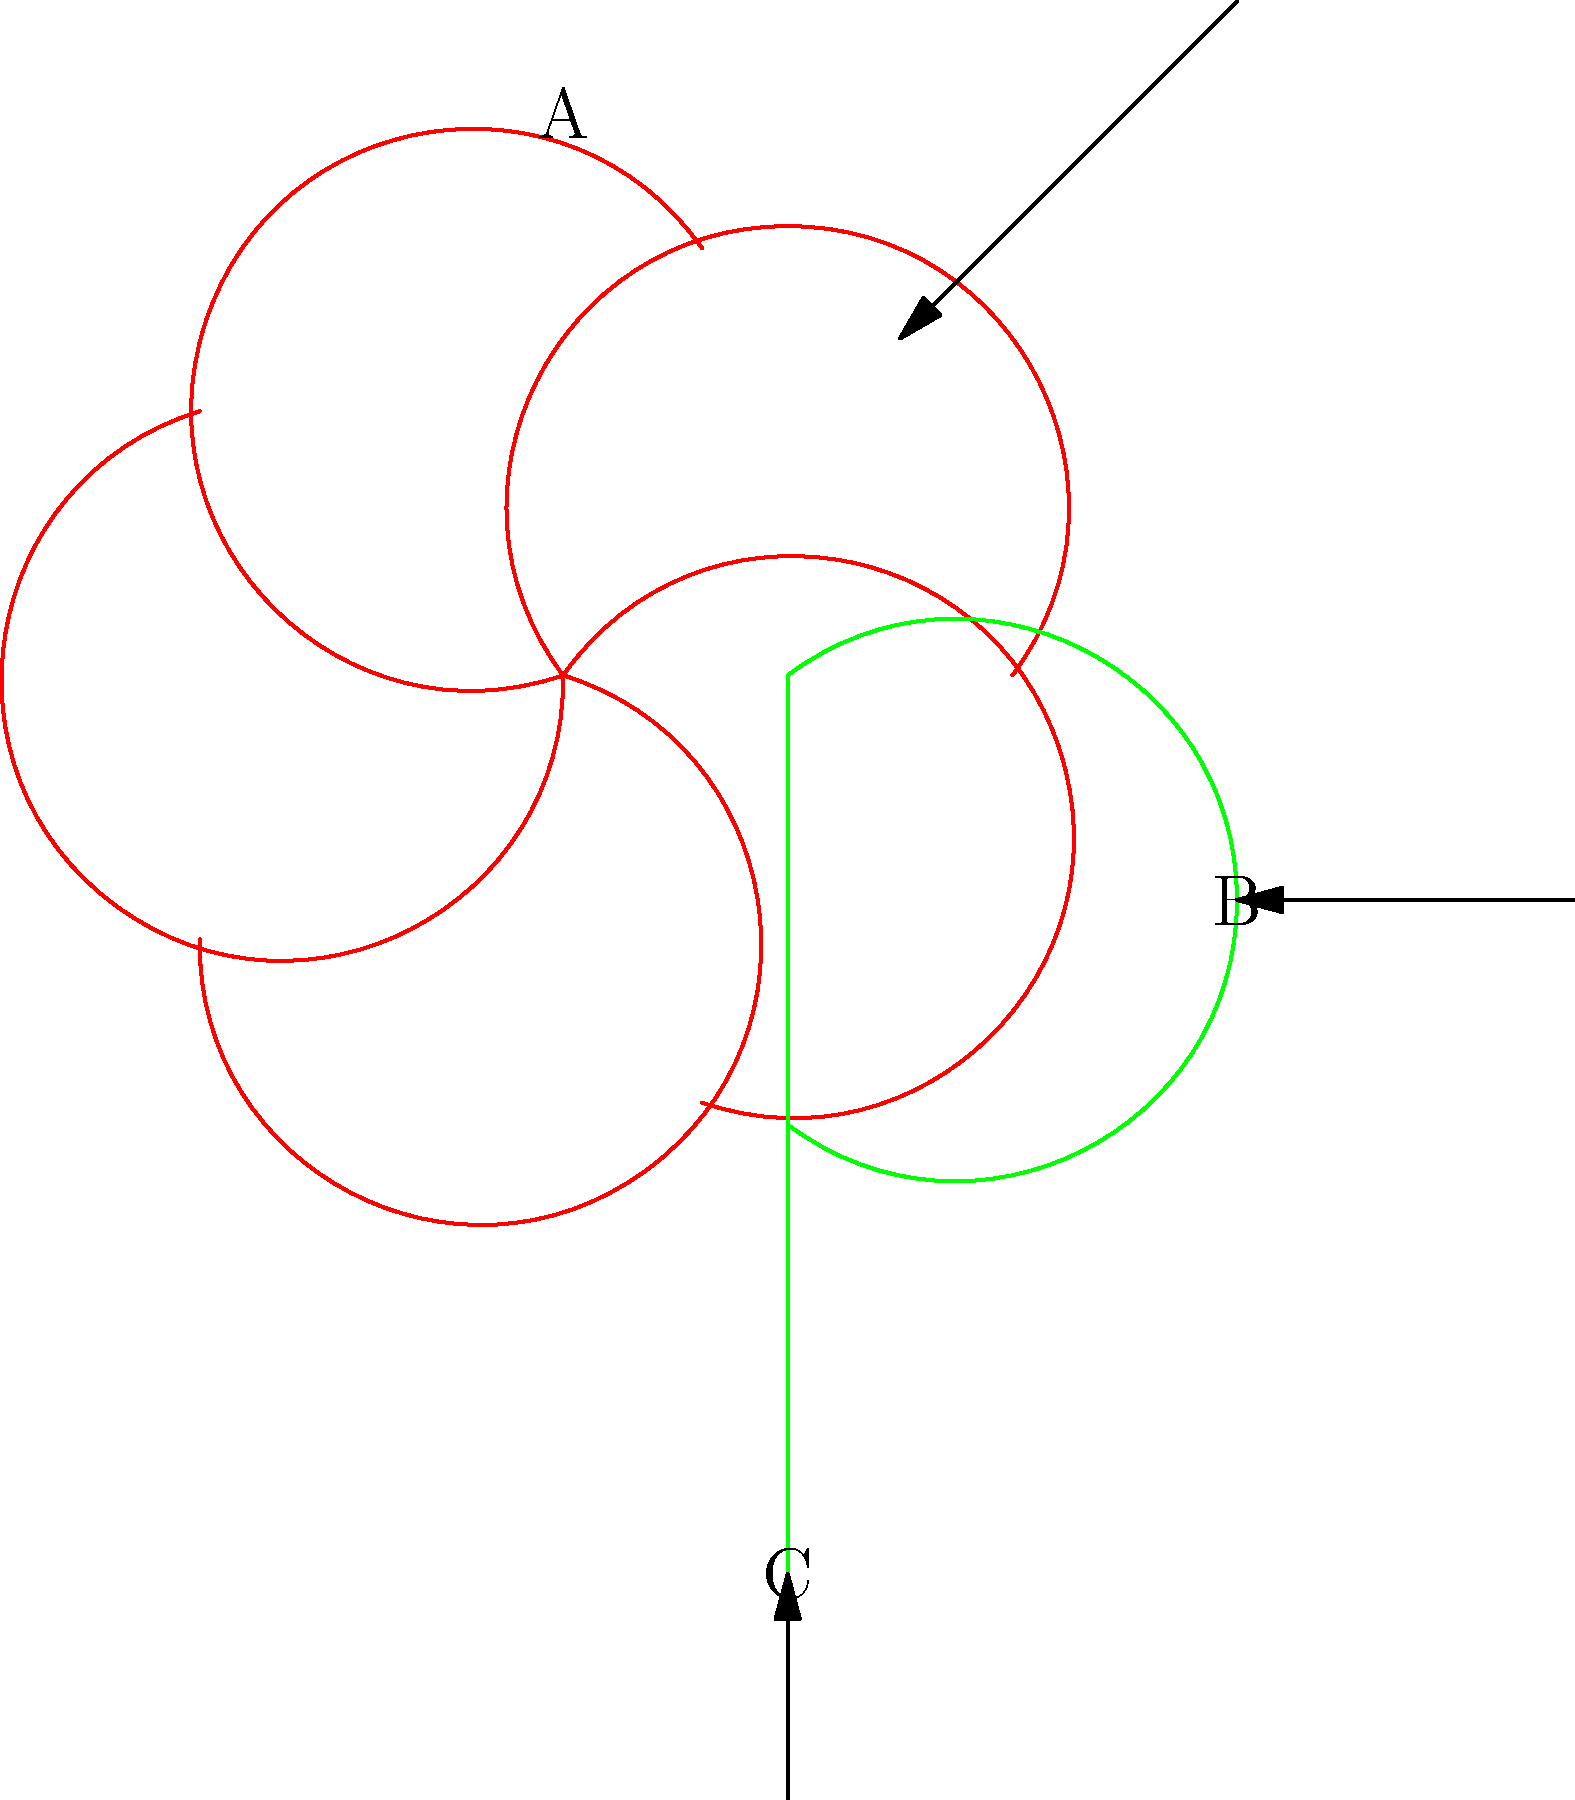Identify the structures labeled A, B, and C in the botanical drawing above. Which of these structures is most useful for taxonomic classification at the family level, and why? To answer this question, let's analyze each labeled structure:

1. Structure A: This represents the flower, which is composed of multiple petals arranged in a radial pattern. Flowers are reproductive structures in angiosperms.

2. Structure B: This is a leaf, an organ primarily responsible for photosynthesis in plants.

3. Structure C: This is the stem, which provides support and conducts water and nutrients throughout the plant.

Among these structures, the flower (A) is most useful for taxonomic classification at the family level. Here's why:

1. Floral characteristics are highly conserved within plant families and are less influenced by environmental factors compared to leaves or stems.

2. Flowers contain multiple features that are taxonomically significant, such as:
   a. Number of petals, sepals, stamens, and carpels
   b. Fusion or separation of floral parts
   c. Symmetry (radial or bilateral)
   d. Position of the ovary (superior, inferior, or half-inferior)

3. Many plant family names are based on floral characteristics (e.g., Asteraceae for the aster-like flower structure, Fabaceae for the bean-like fruit that develops from the flower).

4. Floral structures are directly involved in reproduction, which is a fundamental aspect of plant evolution and speciation.

5. Leaves (B) and stems (C), while important for plant identification, are more variable within families and are often more useful for distinguishing between genera or species rather than families.

Therefore, the flower (Structure A) provides the most reliable and informative characteristics for taxonomic classification at the family level in flowering plants.
Answer: Structure A (flower), due to its conserved characteristics within families and direct involvement in reproduction. 